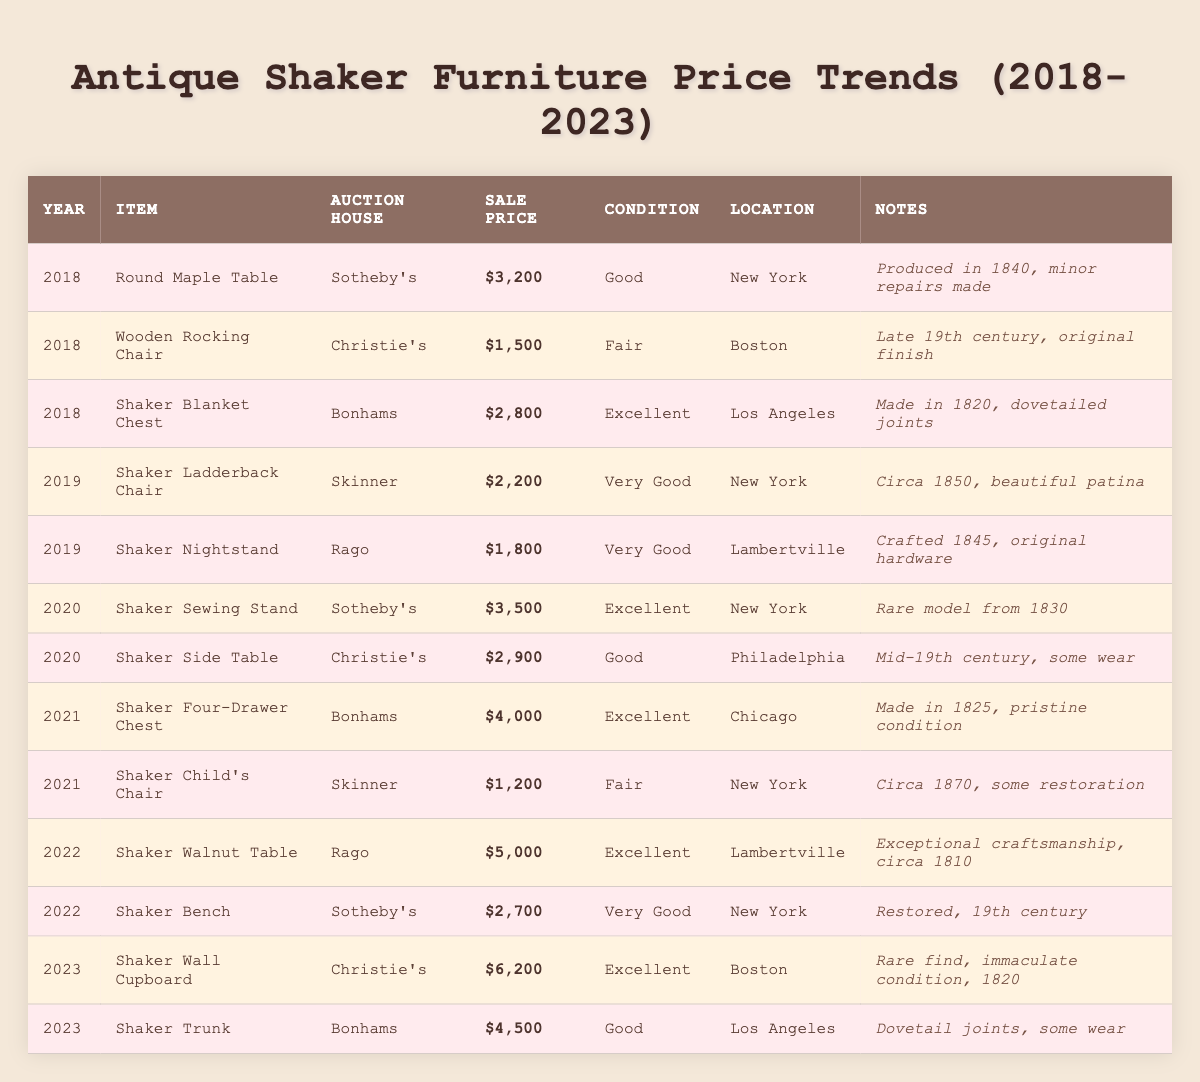What was the highest sale price recorded for antique Shaker furniture from 2018 to 2023? By examining the "Sale Price" column in the table, the highest sale price is $6,200 for the "Shaker Wall Cupboard" sold in 2023.
Answer: $6,200 Which auction house recorded the most sales for Shaker furniture during this period? Reviewing the table, Christie's appears three times, while Sotheby's and Bonhams each appear three times as well. Rago has two instances. Therefore, no auction house has a clear majority.
Answer: None What was the average sale price of Shaker furniture in 2021? In 2021, there are two items with sale prices: $4,000 for the "Shaker Four-Drawer Chest" and $1,200 for the "Shaker Child's Chair." The average is calculated as (4,000 + 1,200) / 2 = 2,600.
Answer: $2,600 How many items were sold in 2020, and what was their total sale price? In 2020, there are two items: "Shaker Sewing Stand" at $3,500 and "Shaker Side Table" at $2,900. Therefore, the total sale price is $3,500 + $2,900 = $6,400. There are 2 items sold.
Answer: 2 items, $6,400 What is the difference in sale price between the "Shaker Walnut Table" and the "Shaker Wall Cupboard"? The sale price of the "Shaker Walnut Table" in 2022 was $5,000 and that of the "Shaker Wall Cupboard" in 2023 was $6,200. The difference is $6,200 - $5,000 = $1,200.
Answer: $1,200 Which item had the best condition in 2018 and what was its sale price? The "Shaker Blanket Chest" was graded as "Excellent" in 2018 and had a sale price of $2,800, as indicated in the table.
Answer: "Shaker Blanket Chest", $2,800 In which year did the "Shaker Four-Drawer Chest" sell, and what was its notable feature? According to the table, the "Shaker Four-Drawer Chest" sold in 2021, and it is noted as being in "pristine condition" and made in 1825.
Answer: 2021, pristine condition How has the average sale price of Shaker furniture changed from 2018 to 2023? By calculating the average sale prices for each year: 2018: ($3,200 + $1,500 + $2,800)/3 = $2,833.33, 2019: ($2,200 + $1,800)/2 = $2,000, 2020: ($3,500 + $2,900)/2 = $3,200, 2021: ($4,000 + $1,200)/2 = $2,600, 2022: ($5,000 + $2,700)/2 = $3,850, 2023: ($6,200 + $4,500)/2 = $5,350. Observing these averages shows an overall upward trend in average sale price.
Answer: Prices increased overall What percentage of the items sold in 2023 were in excellent condition? In 2023, there are two items: the "Shaker Wall Cupboard" (Excellent) and the "Shaker Trunk" (Good). Since only one of the two items is in excellent condition, the percentage is (1/2) * 100 = 50%.
Answer: 50% 